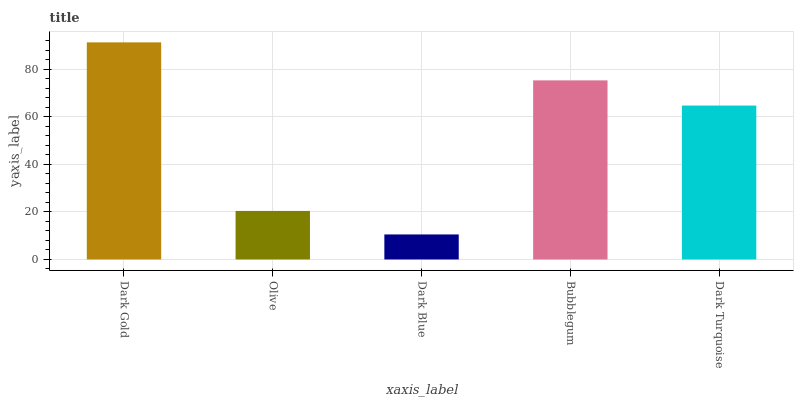Is Dark Blue the minimum?
Answer yes or no. Yes. Is Dark Gold the maximum?
Answer yes or no. Yes. Is Olive the minimum?
Answer yes or no. No. Is Olive the maximum?
Answer yes or no. No. Is Dark Gold greater than Olive?
Answer yes or no. Yes. Is Olive less than Dark Gold?
Answer yes or no. Yes. Is Olive greater than Dark Gold?
Answer yes or no. No. Is Dark Gold less than Olive?
Answer yes or no. No. Is Dark Turquoise the high median?
Answer yes or no. Yes. Is Dark Turquoise the low median?
Answer yes or no. Yes. Is Dark Blue the high median?
Answer yes or no. No. Is Dark Gold the low median?
Answer yes or no. No. 